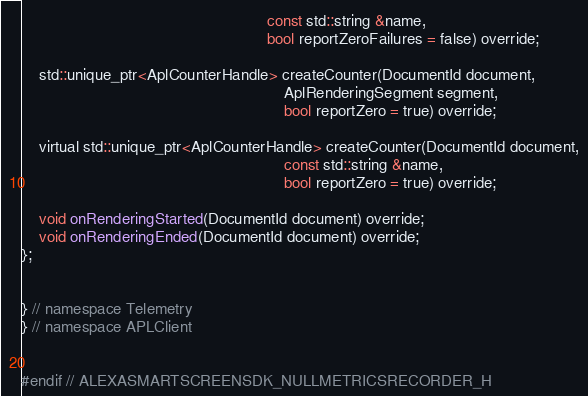Convert code to text. <code><loc_0><loc_0><loc_500><loc_500><_C_>                                                        const std::string &name,
                                                        bool reportZeroFailures = false) override;

    std::unique_ptr<AplCounterHandle> createCounter(DocumentId document,
                                                            AplRenderingSegment segment,
                                                            bool reportZero = true) override;

    virtual std::unique_ptr<AplCounterHandle> createCounter(DocumentId document,
                                                            const std::string &name,
                                                            bool reportZero = true) override;

    void onRenderingStarted(DocumentId document) override;
    void onRenderingEnded(DocumentId document) override;
};


} // namespace Telemetry
} // namespace APLClient


#endif // ALEXASMARTSCREENSDK_NULLMETRICSRECORDER_H</code> 